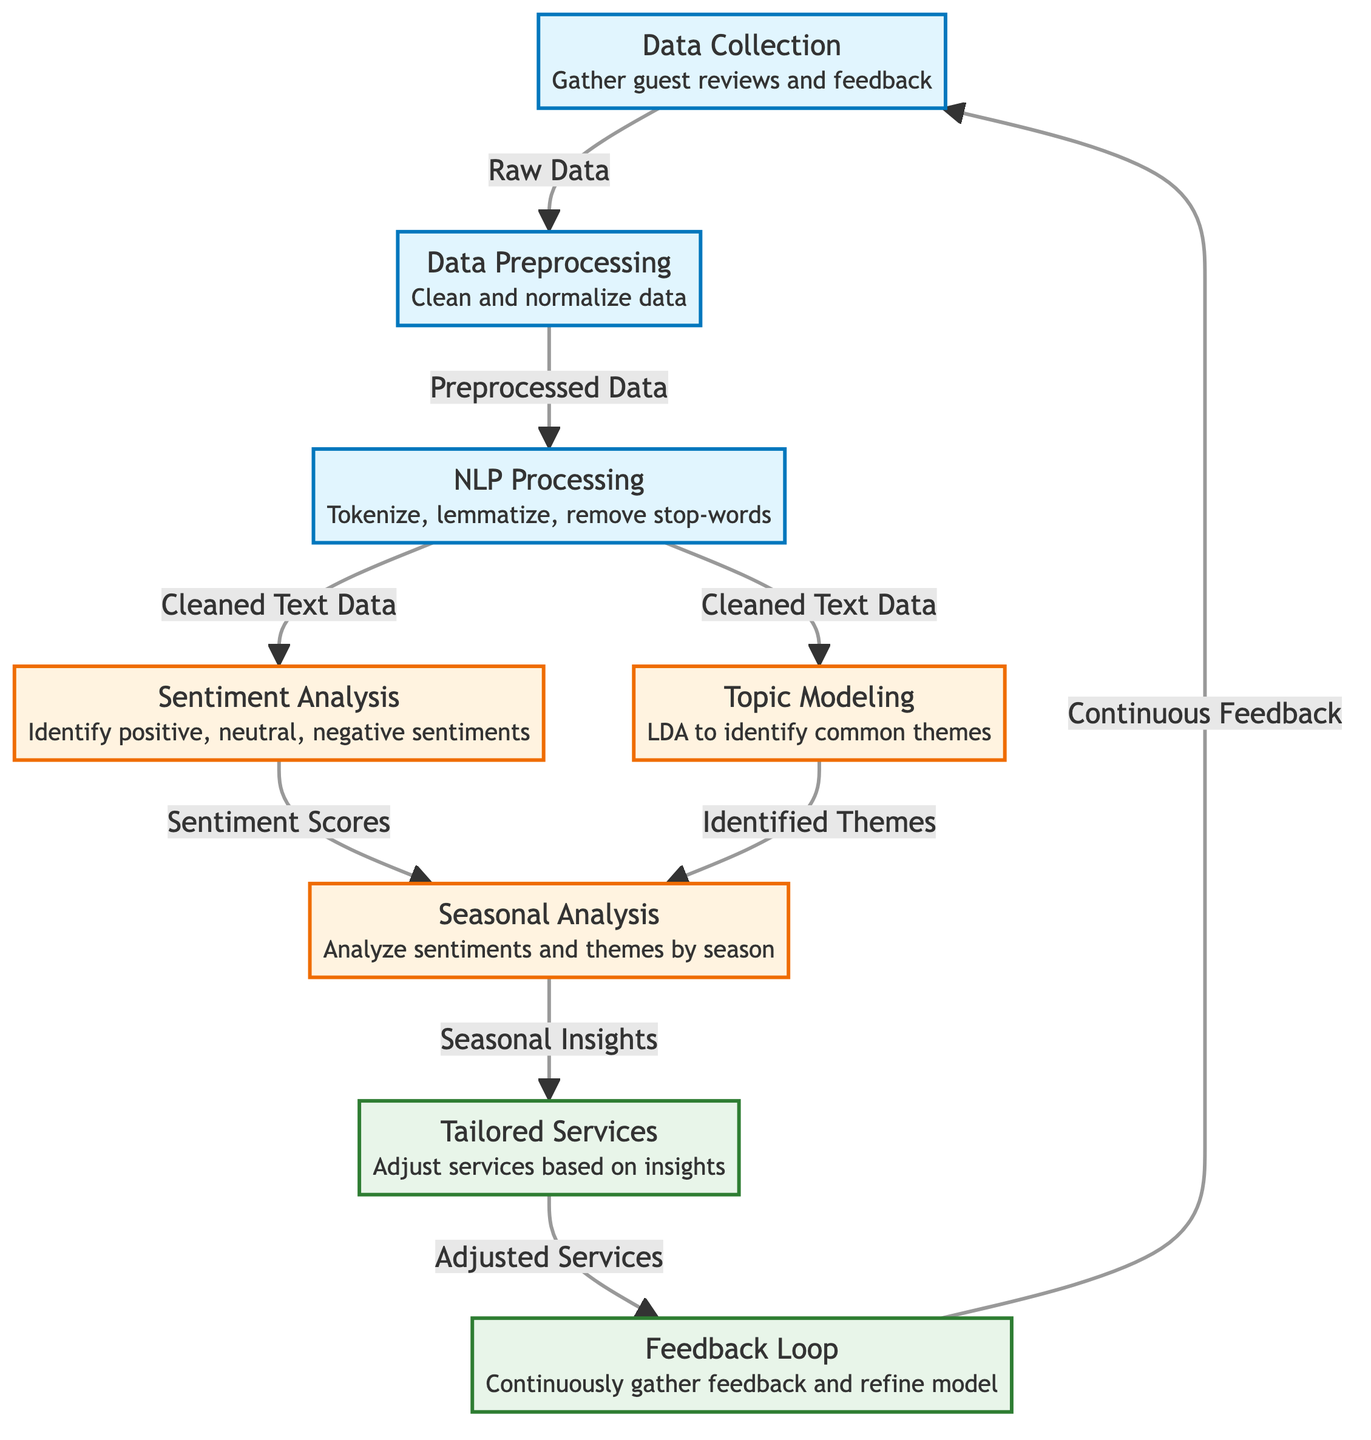What is the first step in the diagram? The first step is "Data Collection," where guest reviews and feedback are gathered. This is the initial action taken in the process flow.
Answer: Data Collection How many analysis nodes are in the diagram? There are three analysis nodes: "Sentiment Analysis," "Topic Modeling," and "Seasonal Analysis." Count the specific nodes designated for analysis in the diagram.
Answer: 3 What do the "Tailored Services" provide? "Tailored Services" provide adjusted services based on insights gathered from the analysis. This node indicates the output produced after analyzing sentiments and themes.
Answer: Adjusted Services Which process follows "NLP Processing"? The processes that follow "NLP Processing" are "Sentiment Analysis" and "Topic Modeling." The diagram shows a branching path from NLP Processing to these two steps.
Answer: Sentiment Analysis and Topic Modeling What is the purpose of the "Feedback Loop"? The purpose of the "Feedback Loop" is to continuously gather feedback and refine the model. This step is crucial for maintaining a cycle of improvement in the overall process.
Answer: Continuous Feedback How does "Seasonal Analysis" utilize input? "Seasonal Analysis" utilizes input from both "Sentiment Scores" and "Identified Themes," as it combines insights from sentiment analysis and topic modeling for comprehensive seasonal insights.
Answer: Sentiment Scores and Identified Themes What is the last output in the diagram? The last output in the diagram is "Continuous Feedback," indicating that the process loops back to the beginning to include ongoing feedback into the data collection step.
Answer: Continuous Feedback 